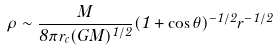Convert formula to latex. <formula><loc_0><loc_0><loc_500><loc_500>\rho \sim \frac { \dot { M } } { 8 \pi r _ { c } ( G M ) ^ { 1 / 2 } } ( 1 + \cos \theta ) ^ { - 1 / 2 } r ^ { - 1 / 2 }</formula> 